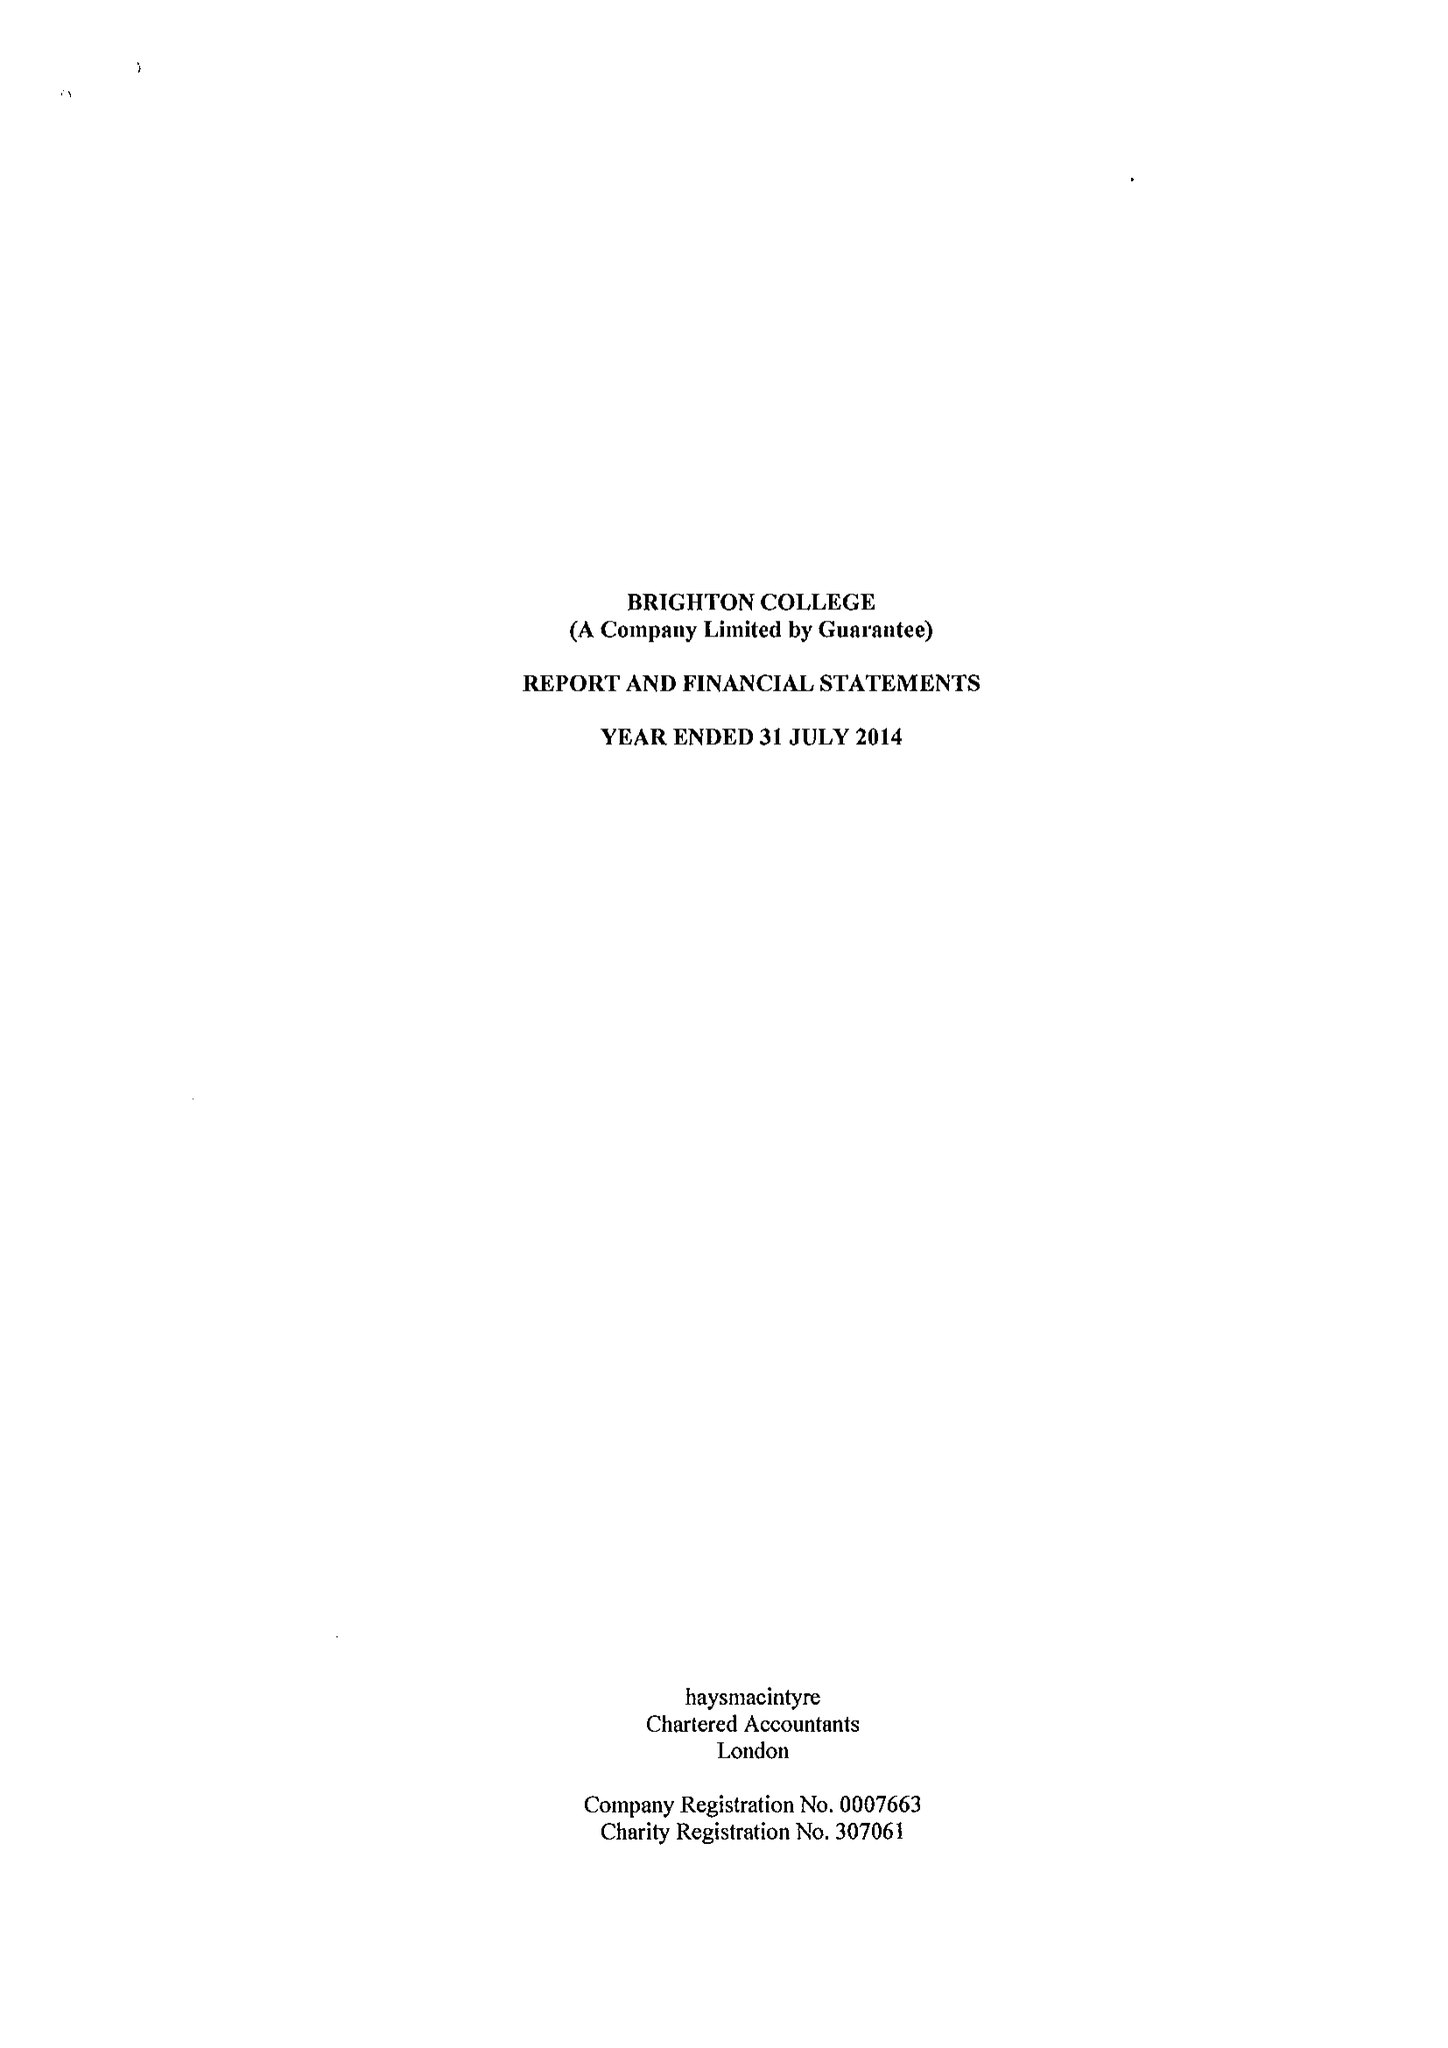What is the value for the address__post_town?
Answer the question using a single word or phrase. BRIGHTON 